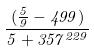<formula> <loc_0><loc_0><loc_500><loc_500>\frac { ( \frac { 5 } { 9 } - 4 9 9 ) } { 5 + 3 5 7 ^ { 2 2 9 } }</formula> 